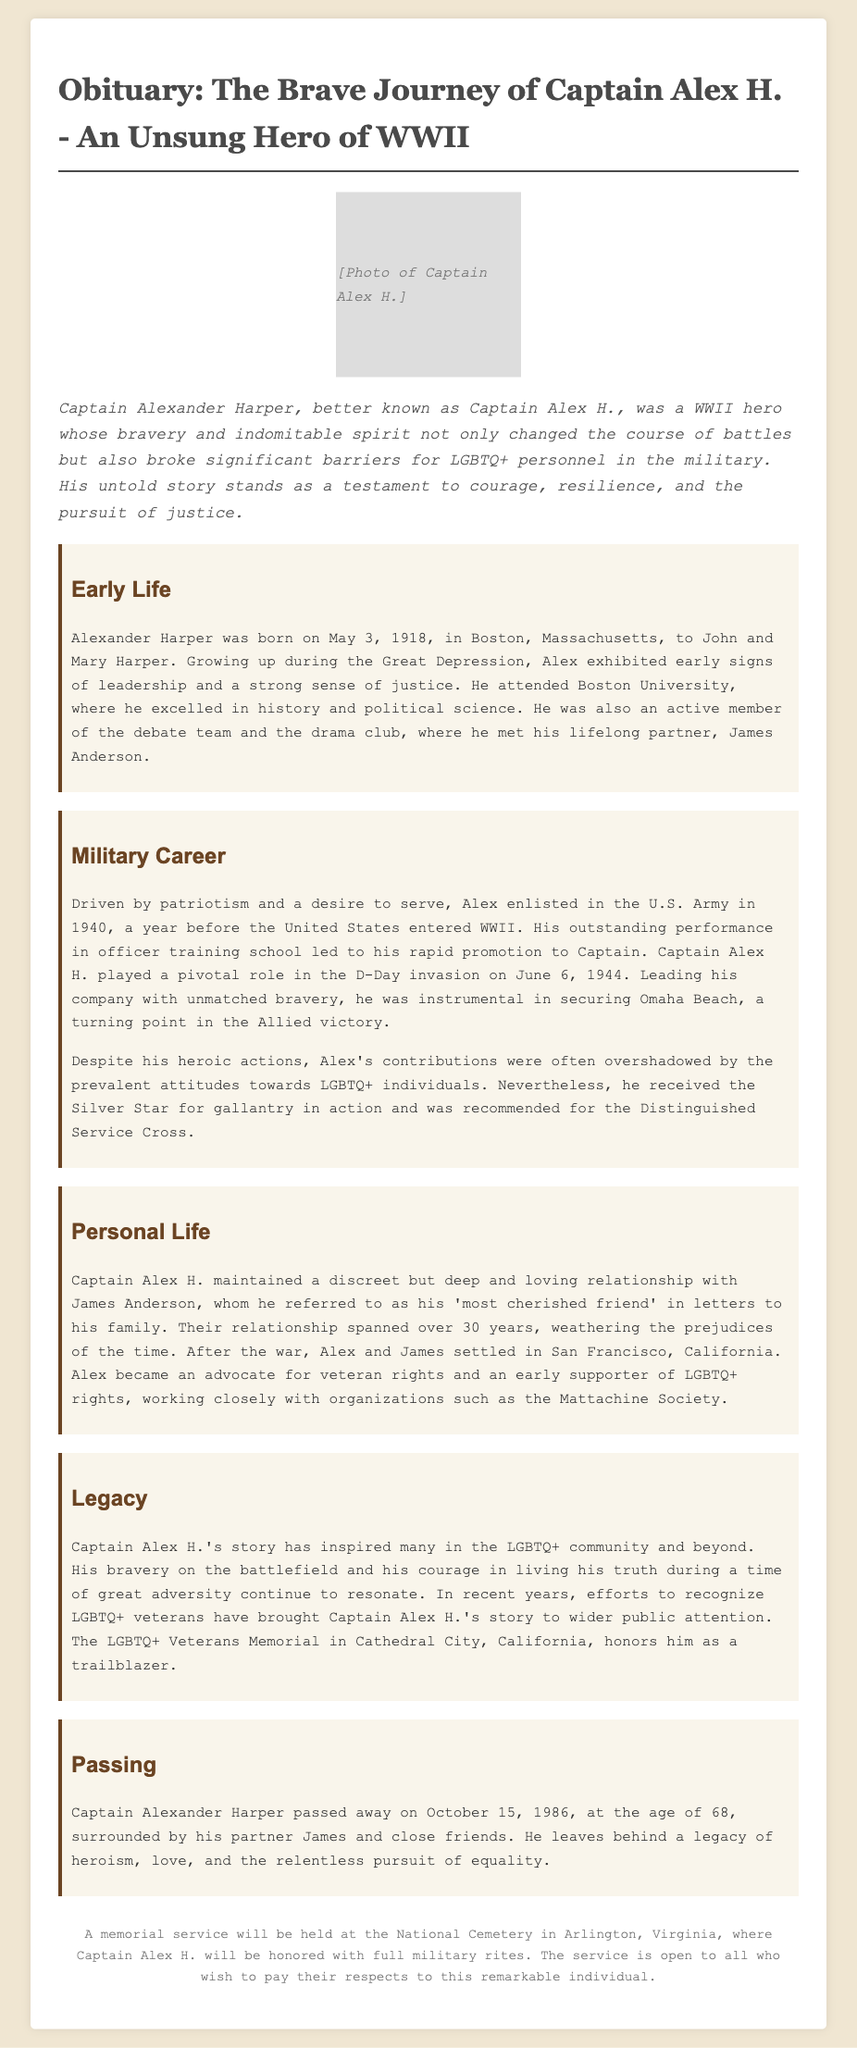What is the full name of Captain Alex H.? The document states his full name as Alexander Harper.
Answer: Alexander Harper When was Captain Alex H. born? The document mentions his birth date as May 3, 1918.
Answer: May 3, 1918 What significant military event did Captain Alex H. participate in? The document highlights his role in the D-Day invasion on June 6, 1944.
Answer: D-Day invasion What award did Captain Alex H. receive for his bravery? The document specifies that he received the Silver Star for gallantry in action.
Answer: Silver Star What city did Captain Alex H. and James Anderson settle in after the war? The document states they settled in San Francisco, California.
Answer: San Francisco Why is Captain Alex H.'s story significant today? The document explains that his story inspires many in the LGBTQ+ community and honors him as a trailblazer.
Answer: LGBTQ+ community When did Captain Alex H. pass away? According to the document, he passed away on October 15, 1986.
Answer: October 15, 1986 What is the name of the memorial that honors Captain Alex H.? The document refers to the LGBTQ+ Veterans Memorial in Cathedral City, California.
Answer: LGBTQ+ Veterans Memorial What was Captain Alex H.'s relationship with James Anderson described as? The document describes their relationship as a "deep and loving relationship."
Answer: Deep and loving 